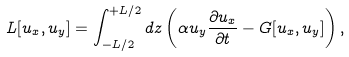<formula> <loc_0><loc_0><loc_500><loc_500>L [ u _ { x } , u _ { y } ] = \int _ { - { L } / { 2 } } ^ { + { L } / { 2 } } d z \left ( { \alpha } u _ { y } \frac { \partial u _ { x } } { \partial t } - G [ u _ { x } , u _ { y } ] \right ) ,</formula> 